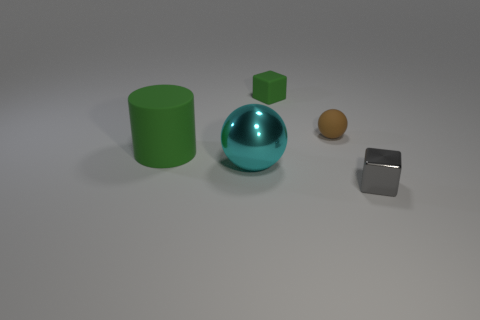Add 1 small yellow cylinders. How many objects exist? 6 Subtract all blocks. How many objects are left? 3 Subtract 0 blue spheres. How many objects are left? 5 Subtract all large red matte blocks. Subtract all big green matte things. How many objects are left? 4 Add 1 big cyan things. How many big cyan things are left? 2 Add 4 big rubber things. How many big rubber things exist? 5 